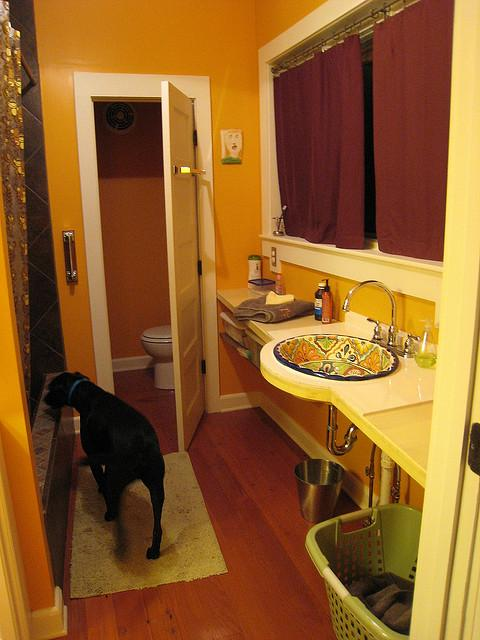What type of dog is this?

Choices:
A) chow
B) black lab
C) poodle
D) chihuahua black lab 